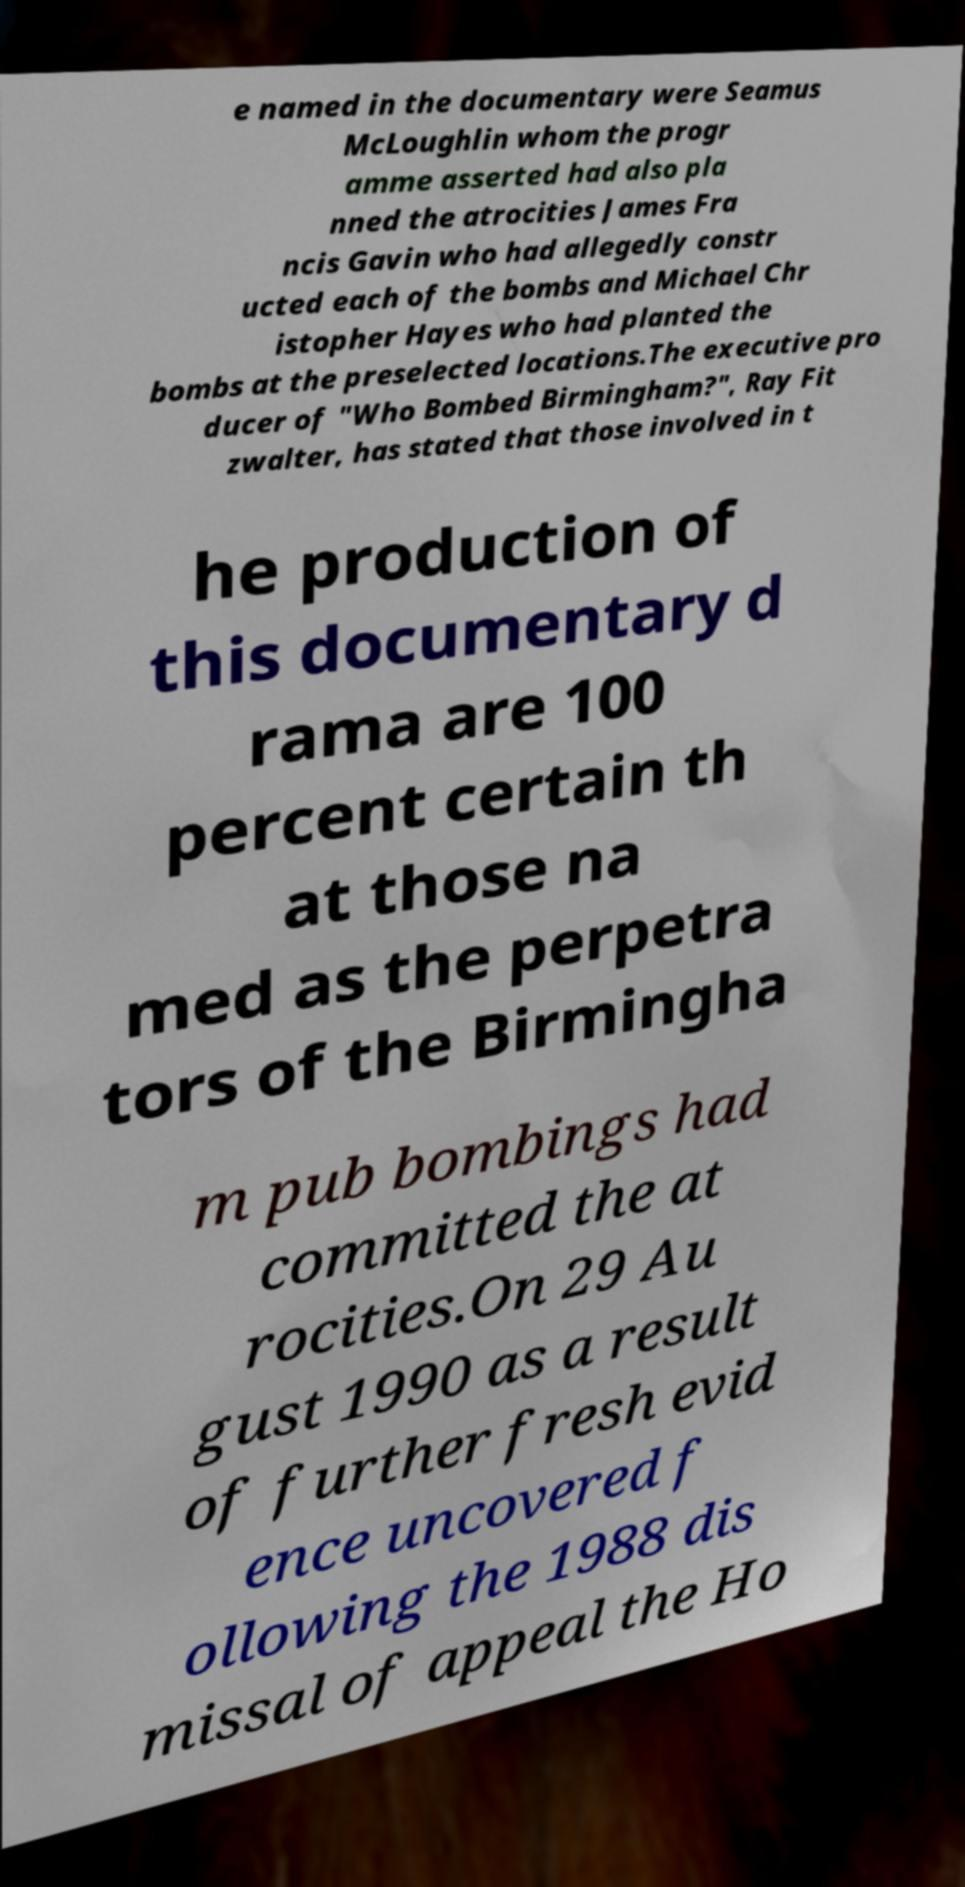Please read and relay the text visible in this image. What does it say? e named in the documentary were Seamus McLoughlin whom the progr amme asserted had also pla nned the atrocities James Fra ncis Gavin who had allegedly constr ucted each of the bombs and Michael Chr istopher Hayes who had planted the bombs at the preselected locations.The executive pro ducer of "Who Bombed Birmingham?", Ray Fit zwalter, has stated that those involved in t he production of this documentary d rama are 100 percent certain th at those na med as the perpetra tors of the Birmingha m pub bombings had committed the at rocities.On 29 Au gust 1990 as a result of further fresh evid ence uncovered f ollowing the 1988 dis missal of appeal the Ho 